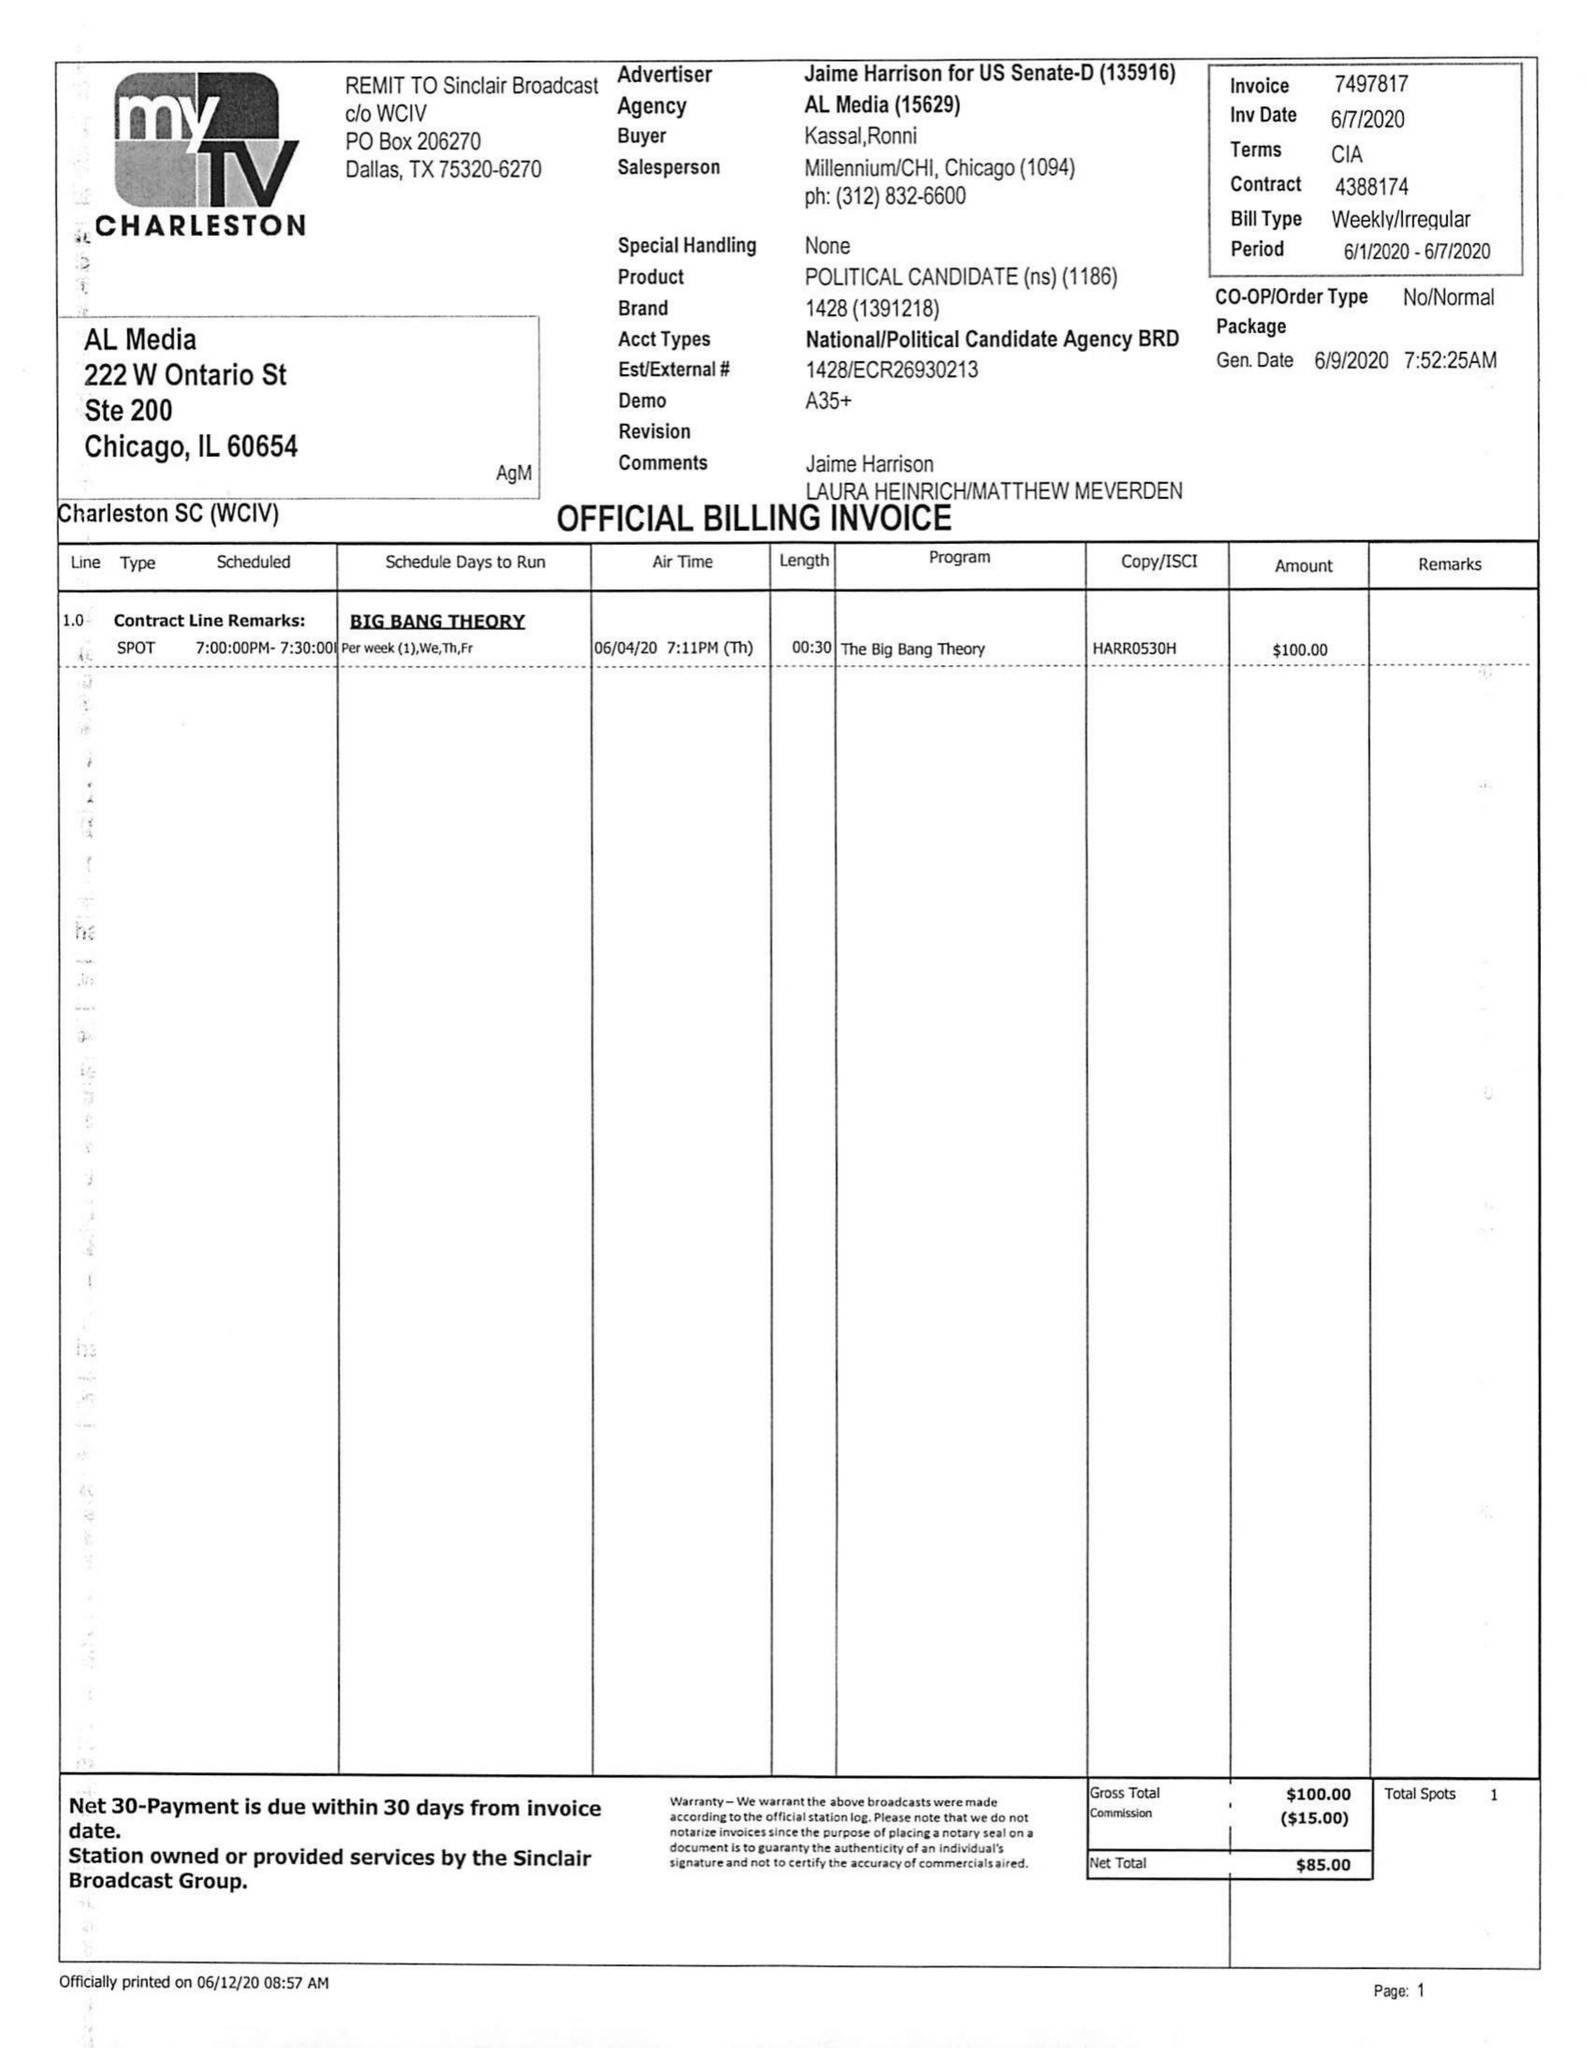What is the value for the flight_from?
Answer the question using a single word or phrase. 06/01/20 